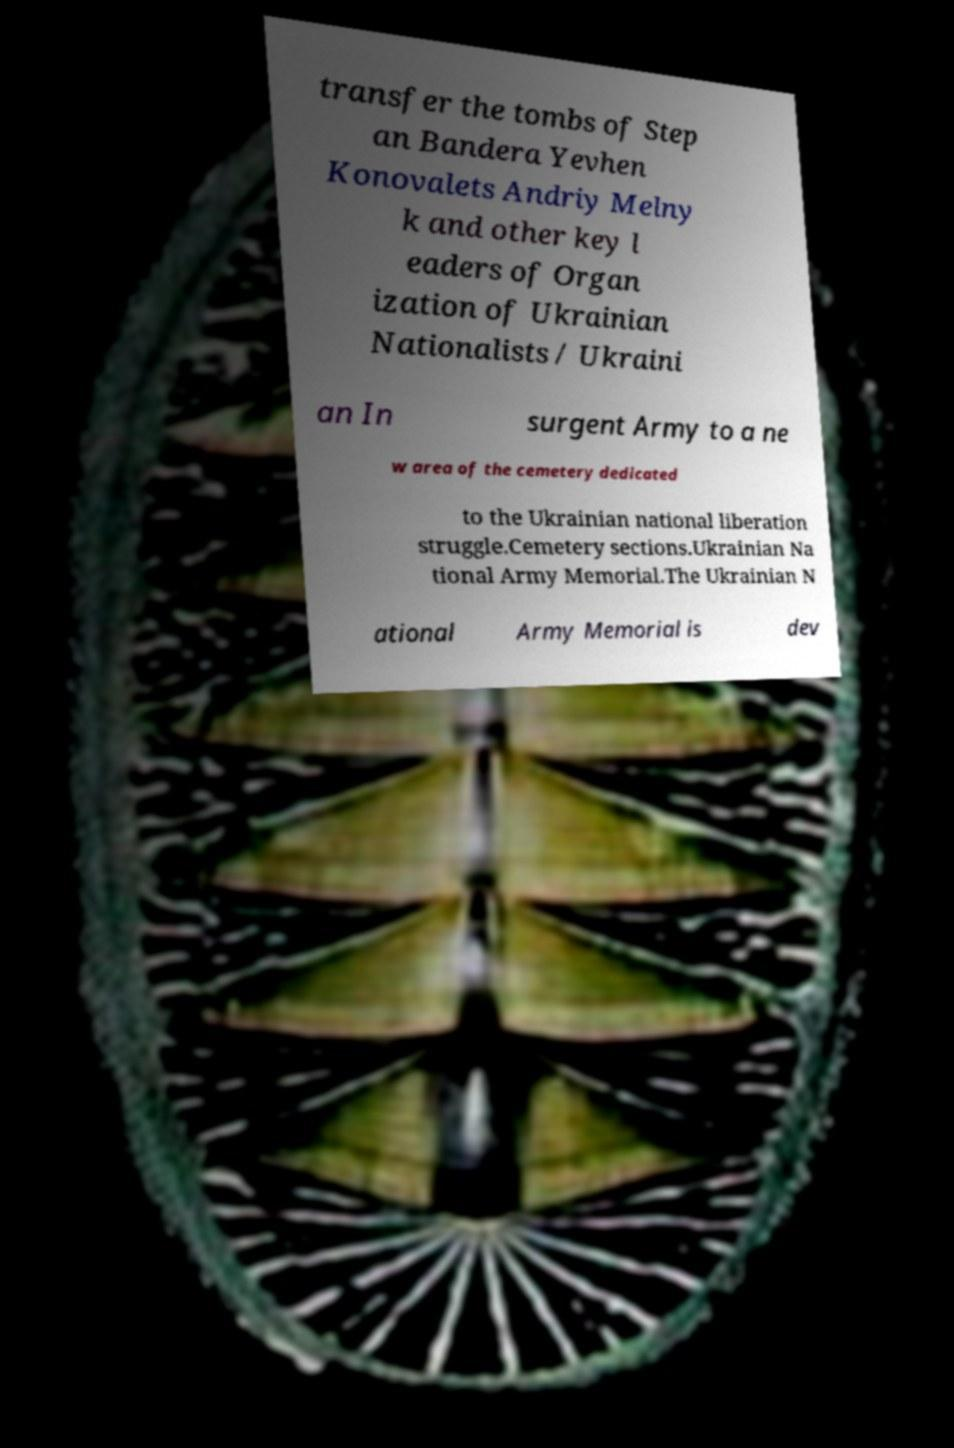Could you assist in decoding the text presented in this image and type it out clearly? transfer the tombs of Step an Bandera Yevhen Konovalets Andriy Melny k and other key l eaders of Organ ization of Ukrainian Nationalists / Ukraini an In surgent Army to a ne w area of the cemetery dedicated to the Ukrainian national liberation struggle.Cemetery sections.Ukrainian Na tional Army Memorial.The Ukrainian N ational Army Memorial is dev 